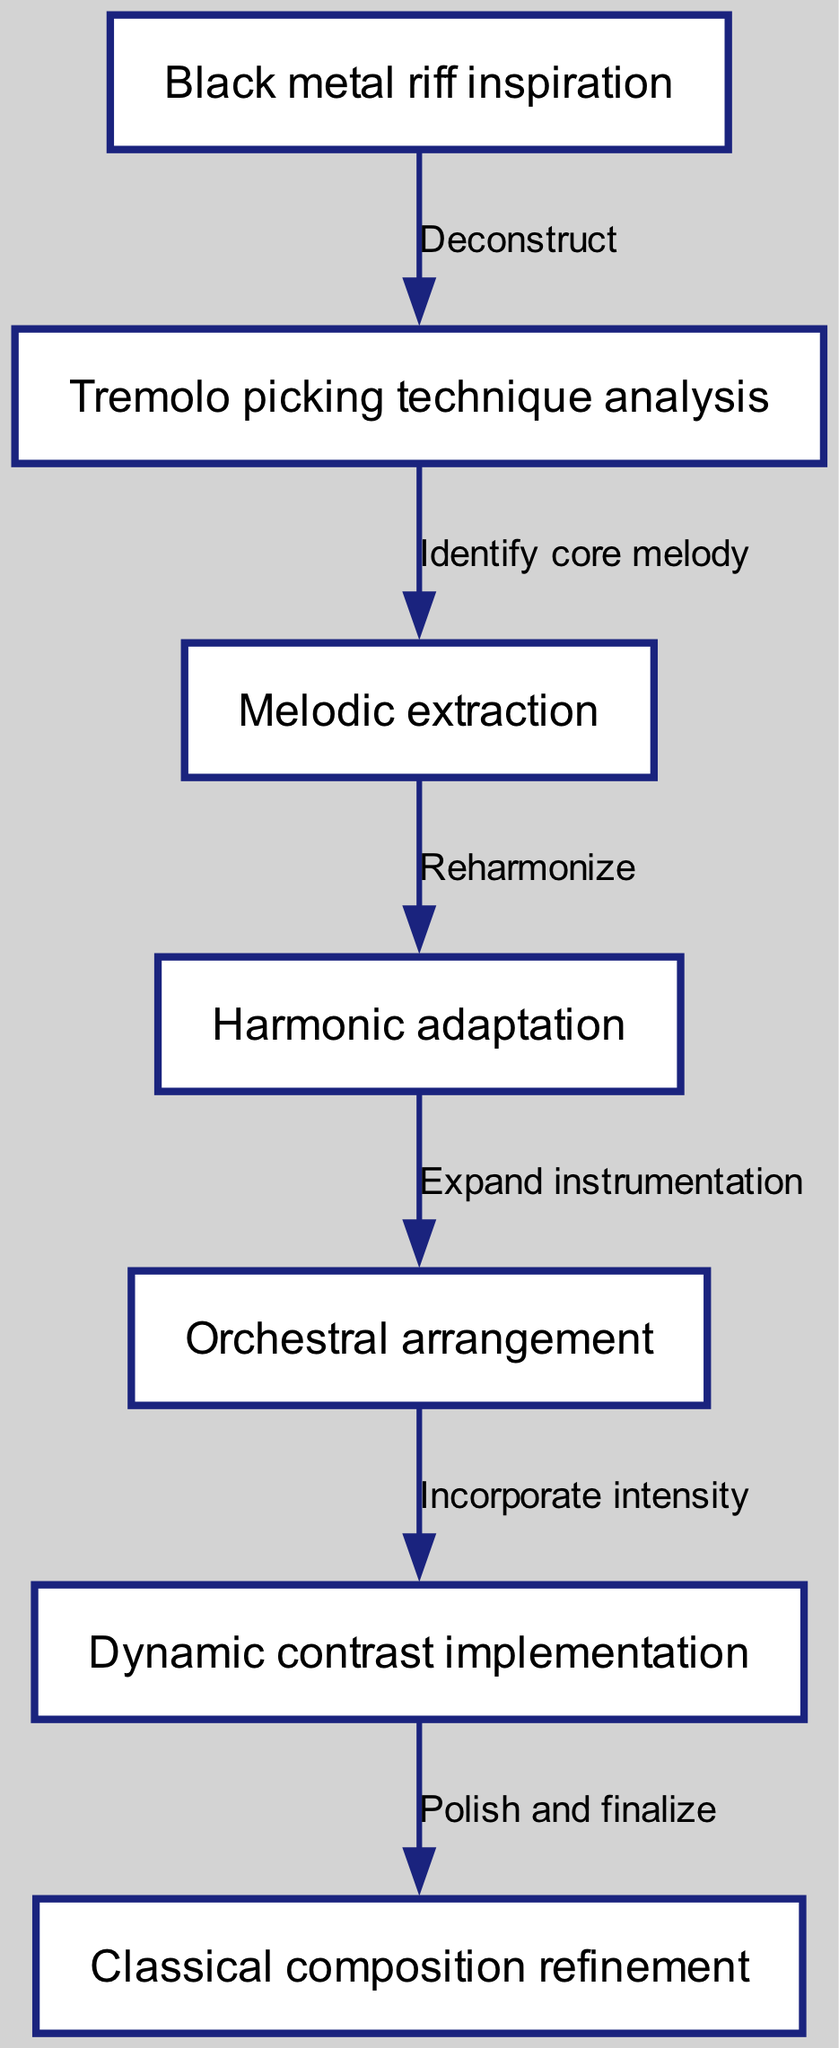What is the first step in the journey of the musical motif? The first step in the journey is represented by the node labeled "Black metal riff inspiration". This node initiates the flow of the diagram, starting the process of transformation.
Answer: Black metal riff inspiration How many nodes are in the diagram? To determine the total number of nodes, we can count them from the diagram. There are seven nodes listed: Black metal riff inspiration, Tremolo picking technique analysis, Melodic extraction, Harmonic adaptation, Orchestral arrangement, Dynamic contrast implementation, and Classical composition refinement.
Answer: 7 What is the relationship between the nodes "Tremolo picking technique analysis" and "Melodic extraction"? The relationship is defined by the edge that connects these two nodes, which is labeled "Identify core melody". This indicates a direct step in the process of extracting melodies derived from the tremolo picking technique.
Answer: Identify core melody What is the final step in the flow of the diagram? The final step is indicated by the node "Classical composition refinement". It represents the last part of the transformation process where everything is polished and finalized.
Answer: Classical composition refinement How many edges lead from the node "Harmonic adaptation"? There is one edge that leads from the node "Harmonic adaptation" to the next node "Orchestral arrangement". This means there is a single step that comes after harmonic adaptation in the process.
Answer: 1 What is the purpose of the node "Dynamic contrast implementation"? This node's purpose is to incorporate intensity into the overall composition. It serves to enhance the dramatic qualities of the orchestral arrangement through dynamic contrasts.
Answer: Incorporate intensity What is the relationship between "Orchestral arrangement" and "Dynamic contrast implementation"? The relationship is established by the edge labeled "Incorporate intensity". This indicates that after arranging for orchestra, the next step involves enhancing the piece by implementing dynamic contrasts.
Answer: Incorporate intensity What is the process between "Melodic extraction" and "Harmonic adaptation"? The process consists of the edge labeled "Reharmonize", indicating that after extracting the melody, the next step is to harmonize it appropriately for the transformation toward classical composition.
Answer: Reharmonize 